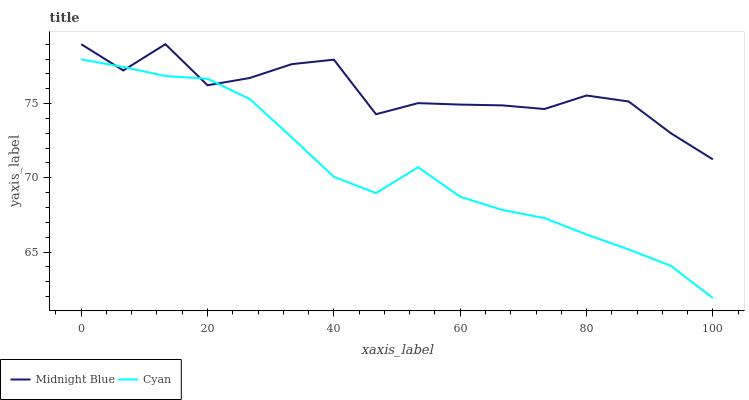Does Cyan have the minimum area under the curve?
Answer yes or no. Yes. Does Midnight Blue have the maximum area under the curve?
Answer yes or no. Yes. Does Midnight Blue have the minimum area under the curve?
Answer yes or no. No. Is Cyan the smoothest?
Answer yes or no. Yes. Is Midnight Blue the roughest?
Answer yes or no. Yes. Is Midnight Blue the smoothest?
Answer yes or no. No. Does Cyan have the lowest value?
Answer yes or no. Yes. Does Midnight Blue have the lowest value?
Answer yes or no. No. Does Midnight Blue have the highest value?
Answer yes or no. Yes. Does Cyan intersect Midnight Blue?
Answer yes or no. Yes. Is Cyan less than Midnight Blue?
Answer yes or no. No. Is Cyan greater than Midnight Blue?
Answer yes or no. No. 